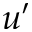<formula> <loc_0><loc_0><loc_500><loc_500>u ^ { \prime }</formula> 